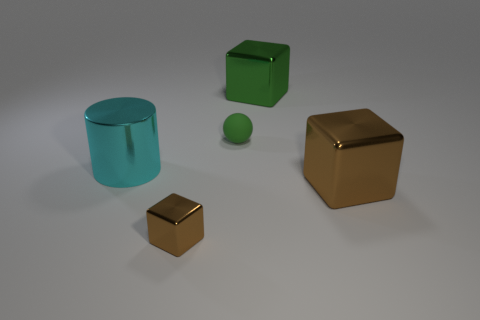How many objects are in the image, and can you describe their shapes? There are five objects in the image: two cubes, one cylinder, one sphere, and one additional item that appears to be a smaller cube. The larger cubes have distinct, sharp edges and flat faces, while the cylinder has smooth, curved surfaces and circular ends. The sphere, of course, is perfectly round, and the smaller cube shares the geometric characteristics of its larger counterparts but on a reduced scale. 